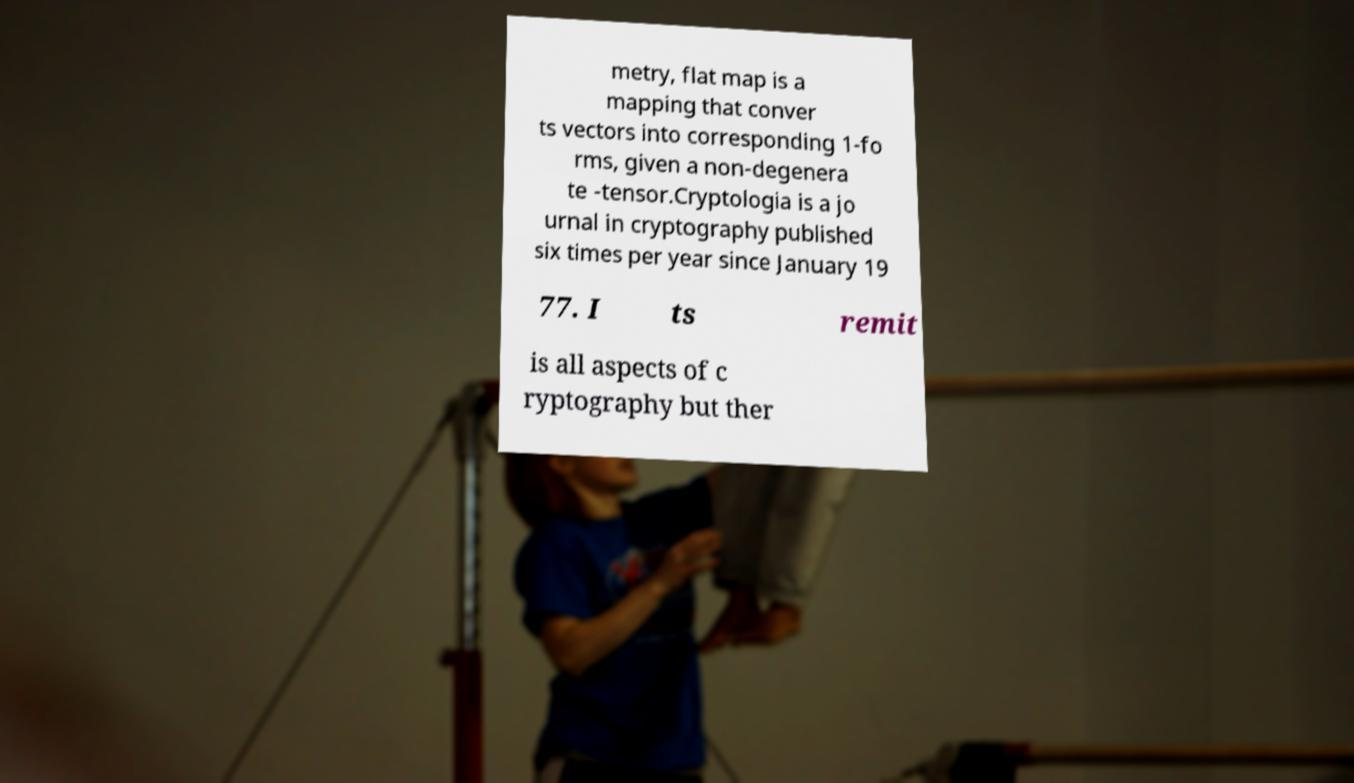For documentation purposes, I need the text within this image transcribed. Could you provide that? metry, flat map is a mapping that conver ts vectors into corresponding 1-fo rms, given a non-degenera te -tensor.Cryptologia is a jo urnal in cryptography published six times per year since January 19 77. I ts remit is all aspects of c ryptography but ther 